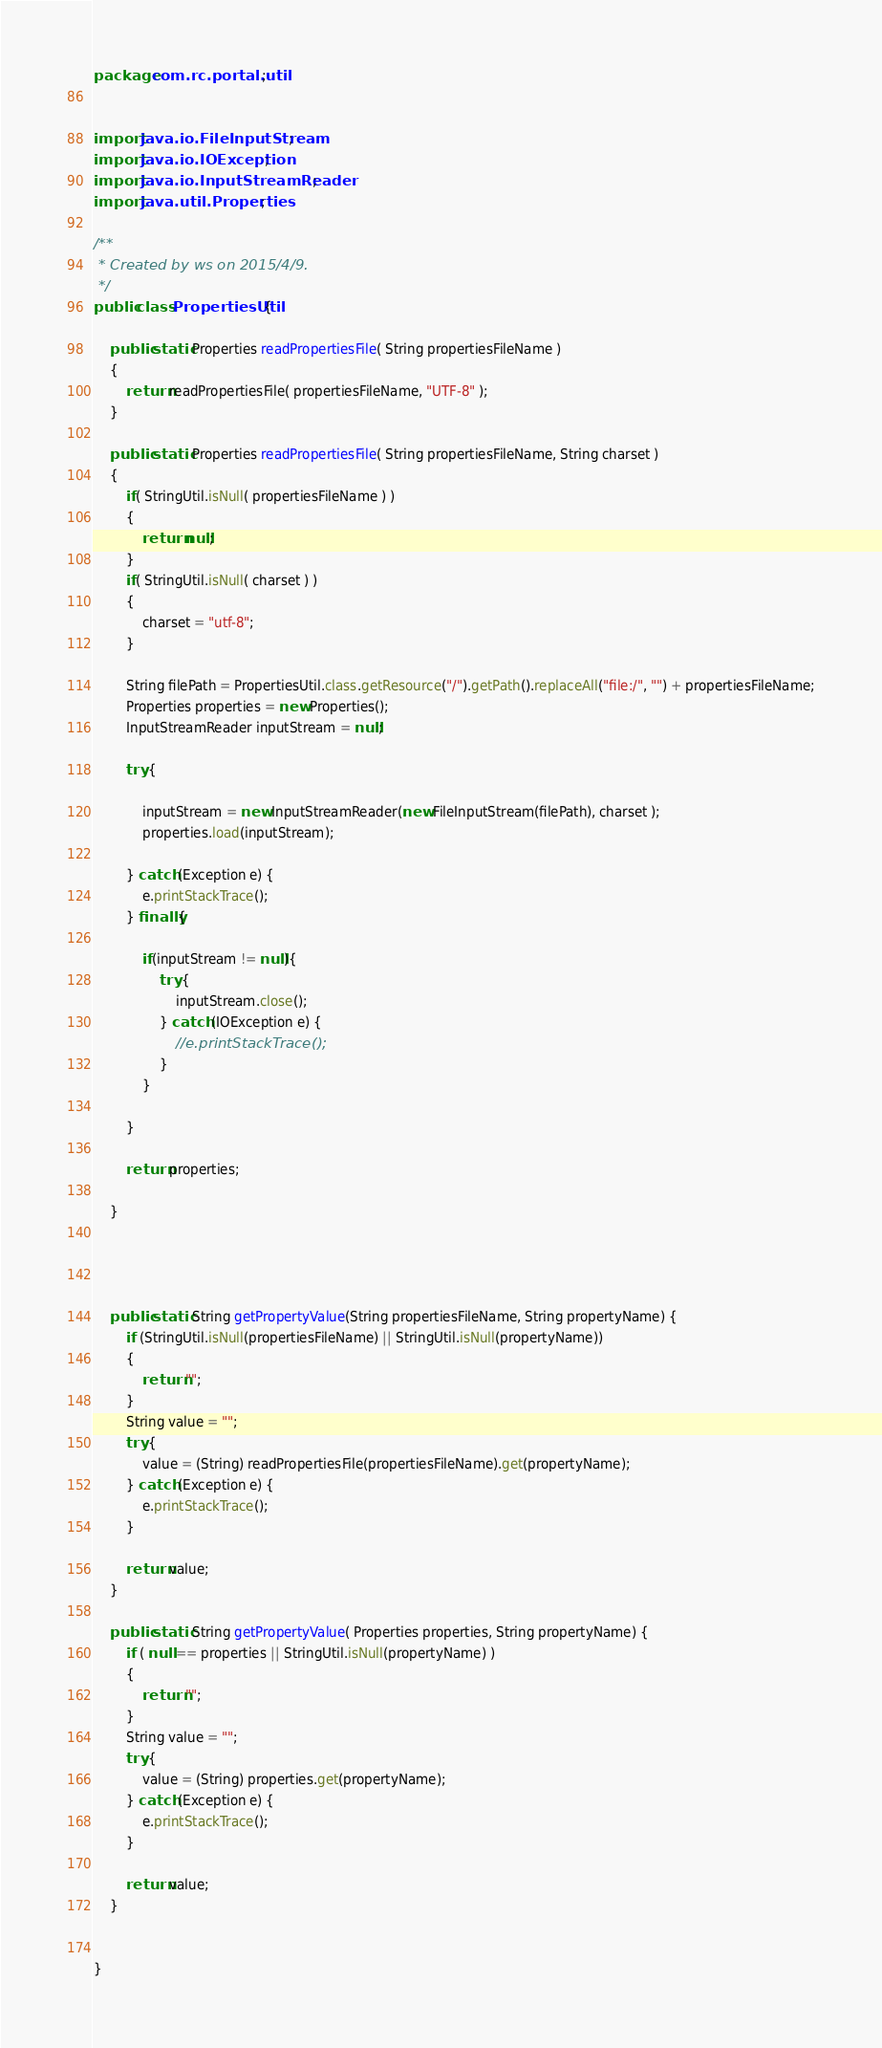Convert code to text. <code><loc_0><loc_0><loc_500><loc_500><_Java_>package com.rc.portal.util;


import java.io.FileInputStream;
import java.io.IOException;
import java.io.InputStreamReader;
import java.util.Properties;

/**
 * Created by ws on 2015/4/9.
 */
public class PropertiesUtil {

    public static Properties readPropertiesFile( String propertiesFileName )
    {
        return readPropertiesFile( propertiesFileName, "UTF-8" );
    }

    public static Properties readPropertiesFile( String propertiesFileName, String charset )
    {
        if( StringUtil.isNull( propertiesFileName ) )
        {
            return null;
        }
        if( StringUtil.isNull( charset ) )
        {
            charset = "utf-8";
        }

        String filePath = PropertiesUtil.class.getResource("/").getPath().replaceAll("file:/", "") + propertiesFileName;
        Properties properties = new Properties();
        InputStreamReader inputStream = null;

        try {

            inputStream = new InputStreamReader(new FileInputStream(filePath), charset );
            properties.load(inputStream);

        } catch (Exception e) {
            e.printStackTrace();
        } finally{

            if(inputStream != null){
                try {
                    inputStream.close();
                } catch (IOException e) {
                    //e.printStackTrace();
                }
            }

        }

        return properties;

    }




    public static String getPropertyValue(String propertiesFileName, String propertyName) {
        if (StringUtil.isNull(propertiesFileName) || StringUtil.isNull(propertyName))
        {
            return "";
        }
        String value = "";
        try {
            value = (String) readPropertiesFile(propertiesFileName).get(propertyName);
        } catch (Exception e) {
            e.printStackTrace();
        }

        return value;
    }

    public static String getPropertyValue( Properties properties, String propertyName) {
        if ( null == properties || StringUtil.isNull(propertyName) )
        {
            return "";
        }
        String value = "";
        try {
            value = (String) properties.get(propertyName);
        } catch (Exception e) {
            e.printStackTrace();
        }

        return value;
    }


}
</code> 